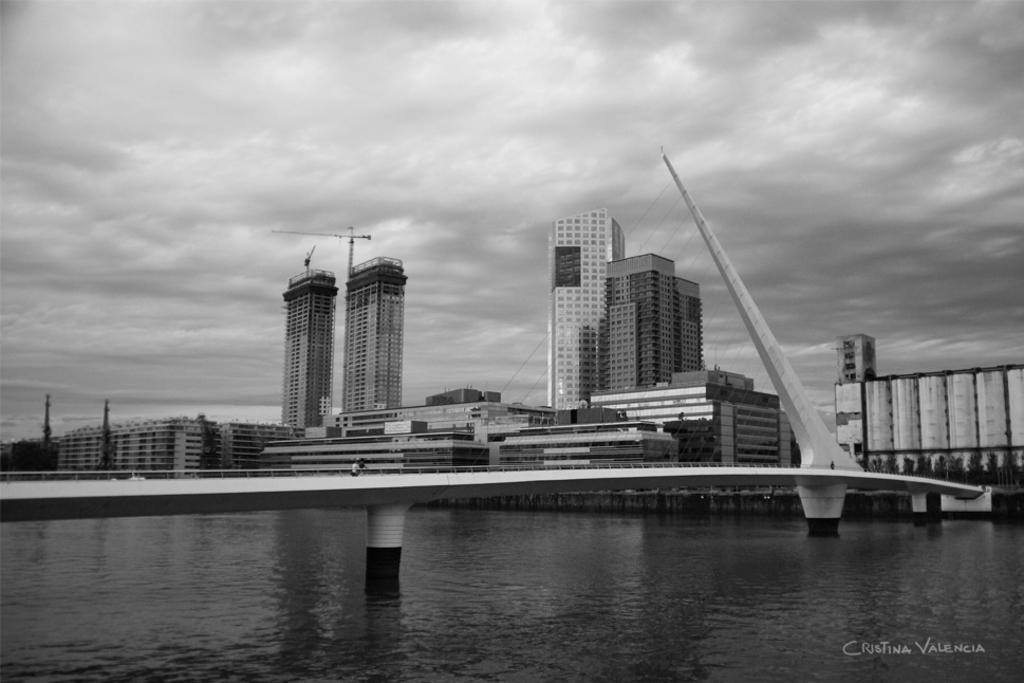What is located in the foreground of the image? There is a body of water, a person, railing, and cables in the foreground of the image. What can be seen in the middle of the image? There are buildings in the middle of the image. What is visible at the top of the image? The sky is visible at the top of the image. How would you describe the sky in the image? The sky is cloudy in the image. What type of zoo animals can be seen in the image? There is no zoo or animals present in the image. What does the caption say about the person in the image? There is no caption present in the image, so we cannot determine what it might say about the person. 